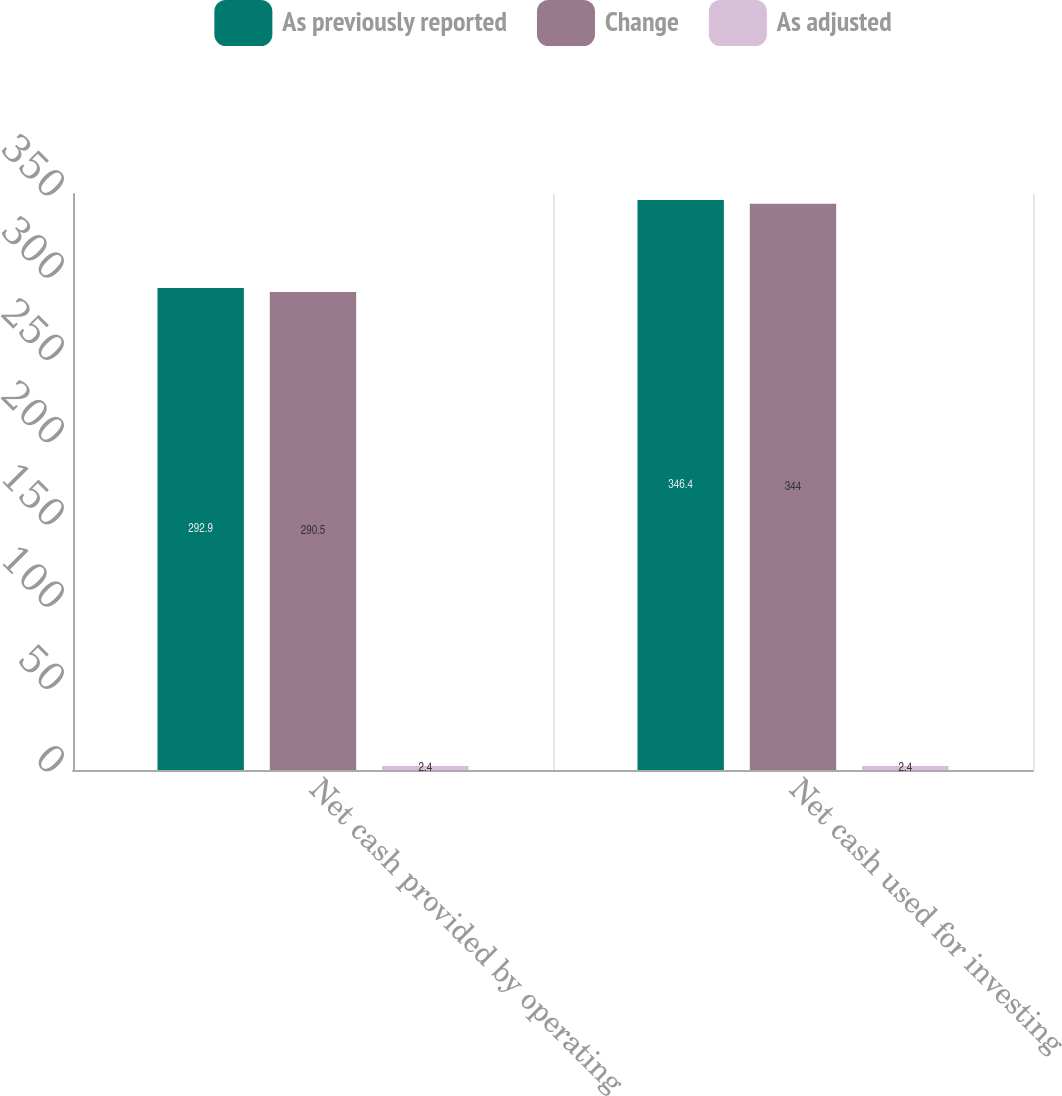<chart> <loc_0><loc_0><loc_500><loc_500><stacked_bar_chart><ecel><fcel>Net cash provided by operating<fcel>Net cash used for investing<nl><fcel>As previously reported<fcel>292.9<fcel>346.4<nl><fcel>Change<fcel>290.5<fcel>344<nl><fcel>As adjusted<fcel>2.4<fcel>2.4<nl></chart> 